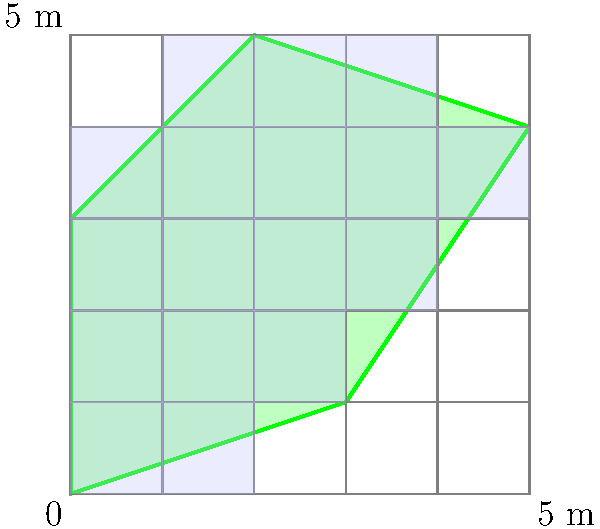A solar panel company representative needs to estimate the area of an irregularly shaped field for a potential installation. The field is overlaid with a grid where each square represents 1 square meter. Full squares within the field are shaded blue, while partial squares are left unshaded. Using the given grid overlay, estimate the area of the field to the nearest square meter. To estimate the area of the irregularly shaped field, we'll follow these steps:

1. Count the number of full squares (shaded blue) within the field:
   Full squares = 11

2. Count the number of partial squares (unshaded, but partially within the field):
   Partial squares = 10

3. Estimate the area covered by partial squares:
   We can approximate that, on average, each partial square contributes about half its area to the field.
   Estimated area of partial squares = $10 \times 0.5 = 5$ square meters

4. Calculate the total estimated area:
   Total area = Full squares + Estimated area of partial squares
               = $11 + 5 = 16$ square meters

5. Round to the nearest square meter:
   The estimated area is already a whole number, so no rounding is necessary.

Therefore, the estimated area of the field is 16 square meters.
Answer: 16 square meters 